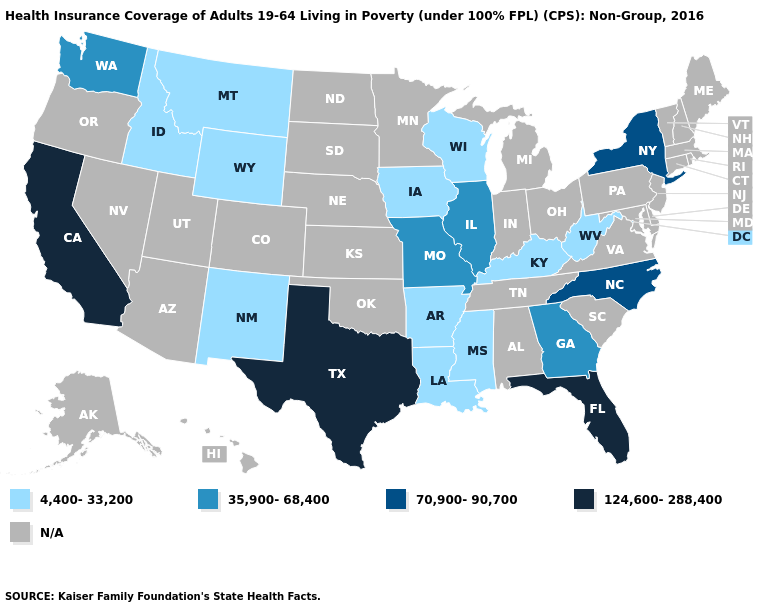Name the states that have a value in the range 70,900-90,700?
Answer briefly. New York, North Carolina. Does Illinois have the lowest value in the MidWest?
Quick response, please. No. Name the states that have a value in the range N/A?
Give a very brief answer. Alabama, Alaska, Arizona, Colorado, Connecticut, Delaware, Hawaii, Indiana, Kansas, Maine, Maryland, Massachusetts, Michigan, Minnesota, Nebraska, Nevada, New Hampshire, New Jersey, North Dakota, Ohio, Oklahoma, Oregon, Pennsylvania, Rhode Island, South Carolina, South Dakota, Tennessee, Utah, Vermont, Virginia. Name the states that have a value in the range N/A?
Keep it brief. Alabama, Alaska, Arizona, Colorado, Connecticut, Delaware, Hawaii, Indiana, Kansas, Maine, Maryland, Massachusetts, Michigan, Minnesota, Nebraska, Nevada, New Hampshire, New Jersey, North Dakota, Ohio, Oklahoma, Oregon, Pennsylvania, Rhode Island, South Carolina, South Dakota, Tennessee, Utah, Vermont, Virginia. What is the highest value in the Northeast ?
Be succinct. 70,900-90,700. Does Georgia have the lowest value in the USA?
Quick response, please. No. Which states have the lowest value in the USA?
Be succinct. Arkansas, Idaho, Iowa, Kentucky, Louisiana, Mississippi, Montana, New Mexico, West Virginia, Wisconsin, Wyoming. Does California have the highest value in the West?
Answer briefly. Yes. Among the states that border Louisiana , which have the lowest value?
Short answer required. Arkansas, Mississippi. What is the value of Louisiana?
Keep it brief. 4,400-33,200. Does Texas have the highest value in the USA?
Short answer required. Yes. Among the states that border Oregon , which have the lowest value?
Quick response, please. Idaho. 